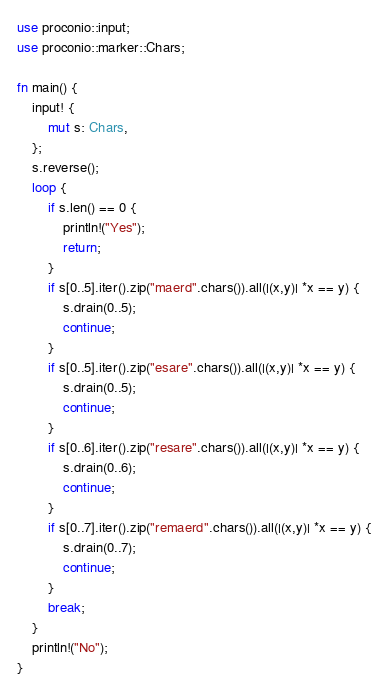<code> <loc_0><loc_0><loc_500><loc_500><_Rust_>use proconio::input;
use proconio::marker::Chars;

fn main() {
    input! {
        mut s: Chars,
    };
    s.reverse();
    loop {
        if s.len() == 0 {
            println!("Yes");
            return;
        }
        if s[0..5].iter().zip("maerd".chars()).all(|(x,y)| *x == y) {
            s.drain(0..5);
            continue;
        }
        if s[0..5].iter().zip("esare".chars()).all(|(x,y)| *x == y) {
            s.drain(0..5);
            continue;
        }
        if s[0..6].iter().zip("resare".chars()).all(|(x,y)| *x == y) {
            s.drain(0..6);
            continue;
        }
        if s[0..7].iter().zip("remaerd".chars()).all(|(x,y)| *x == y) {
            s.drain(0..7);
            continue;
        }
        break;
    }
    println!("No");
}
</code> 